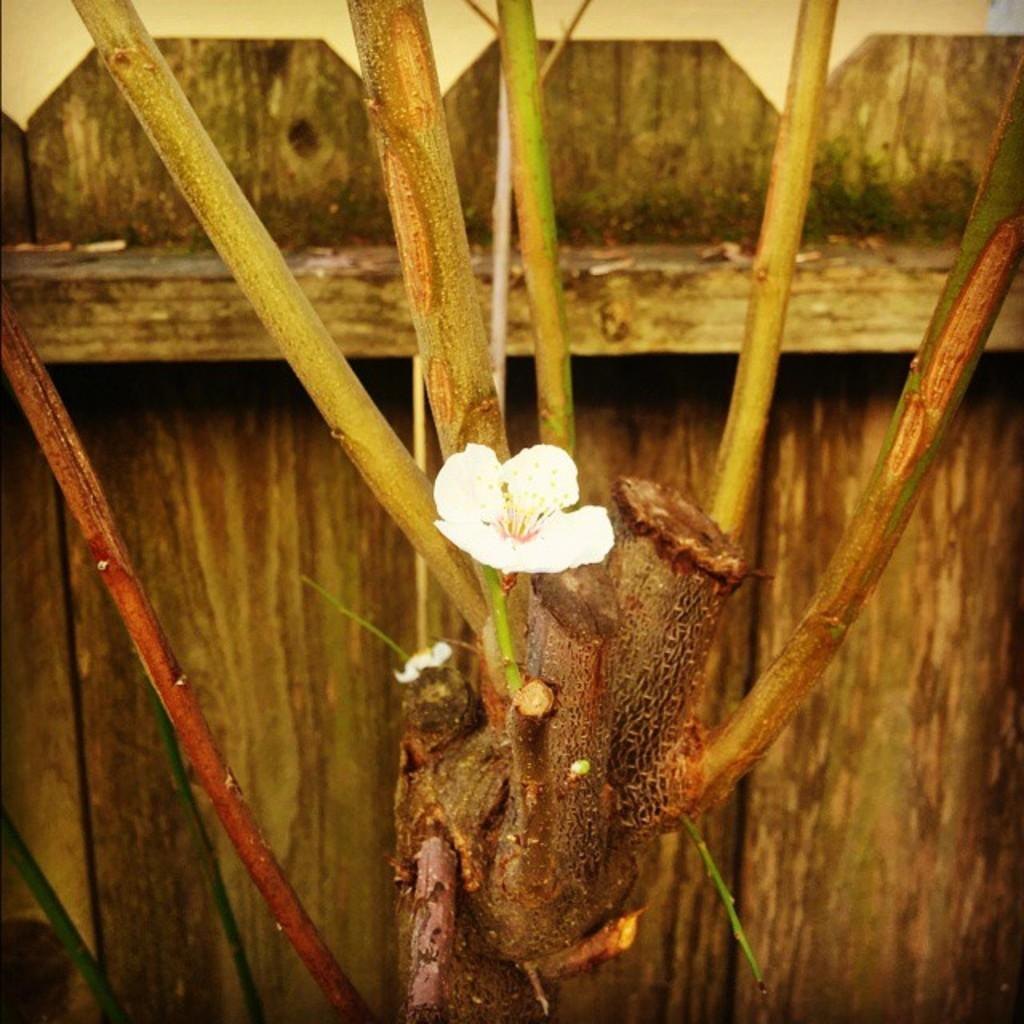What is the main subject in the center of the image? There is a plant in the center of the image. What can be seen on the plant? There is a flower on the plant. What type of material is used for the wall in the background? There is a wooden wall in the background of the image. What type of neck accessory is visible on the plant in the image? There is no neck accessory present on the plant in the image. 